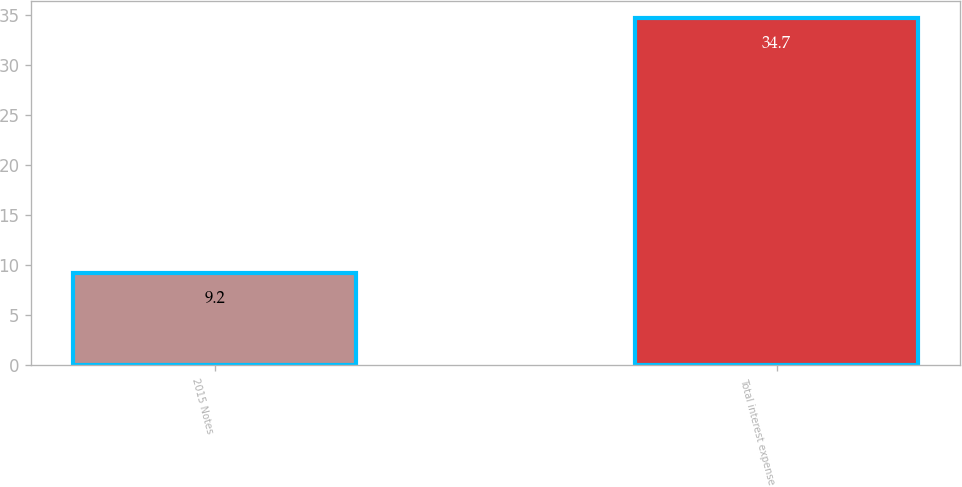<chart> <loc_0><loc_0><loc_500><loc_500><bar_chart><fcel>2015 Notes<fcel>Total interest expense<nl><fcel>9.2<fcel>34.7<nl></chart> 